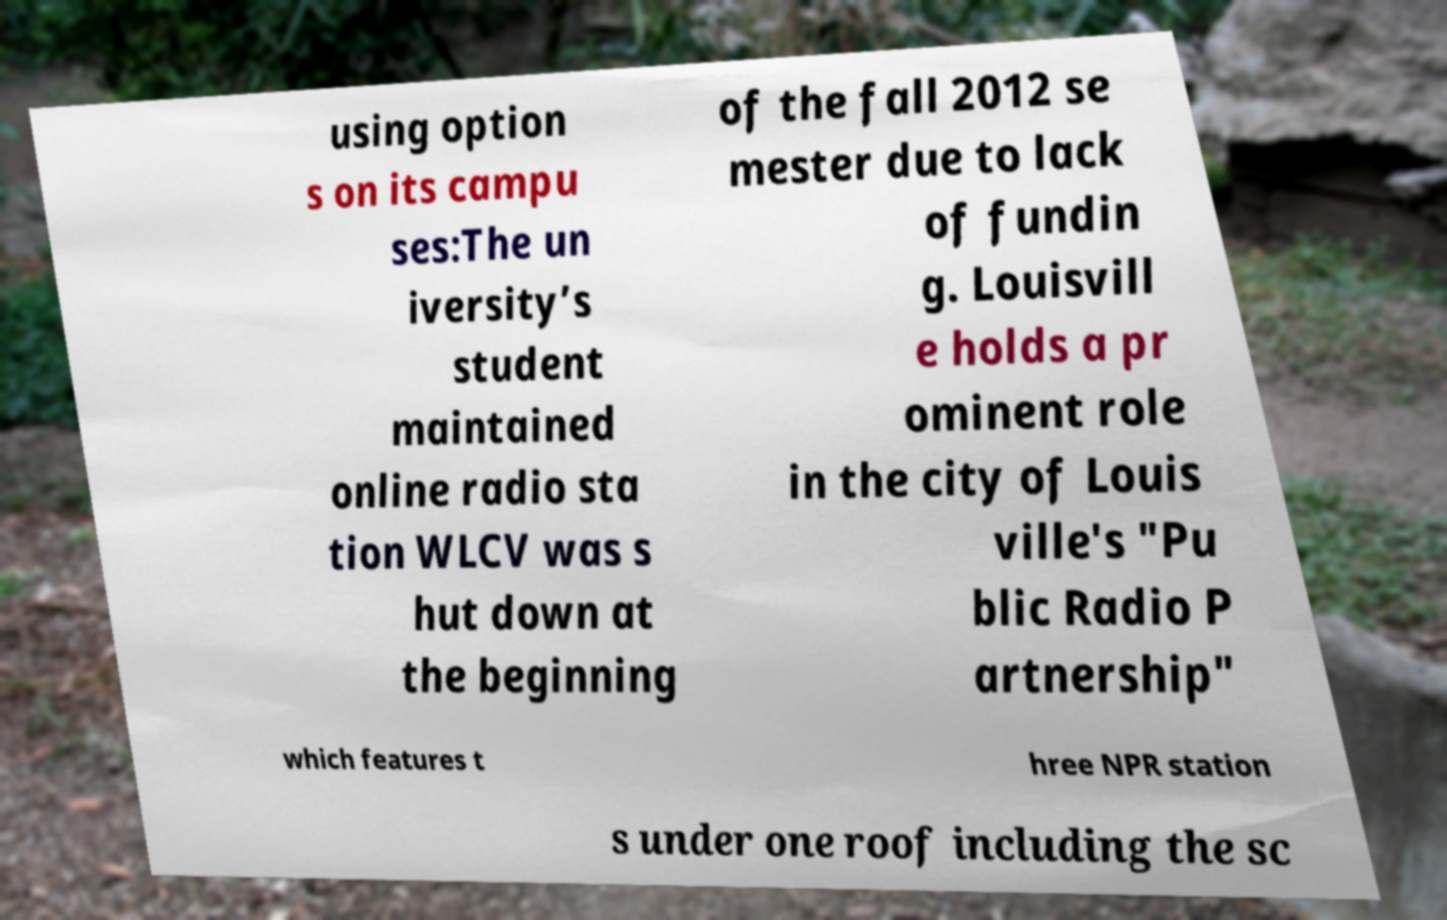Could you extract and type out the text from this image? using option s on its campu ses:The un iversity’s student maintained online radio sta tion WLCV was s hut down at the beginning of the fall 2012 se mester due to lack of fundin g. Louisvill e holds a pr ominent role in the city of Louis ville's "Pu blic Radio P artnership" which features t hree NPR station s under one roof including the sc 